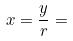Convert formula to latex. <formula><loc_0><loc_0><loc_500><loc_500>x = \frac { y } { r } =</formula> 